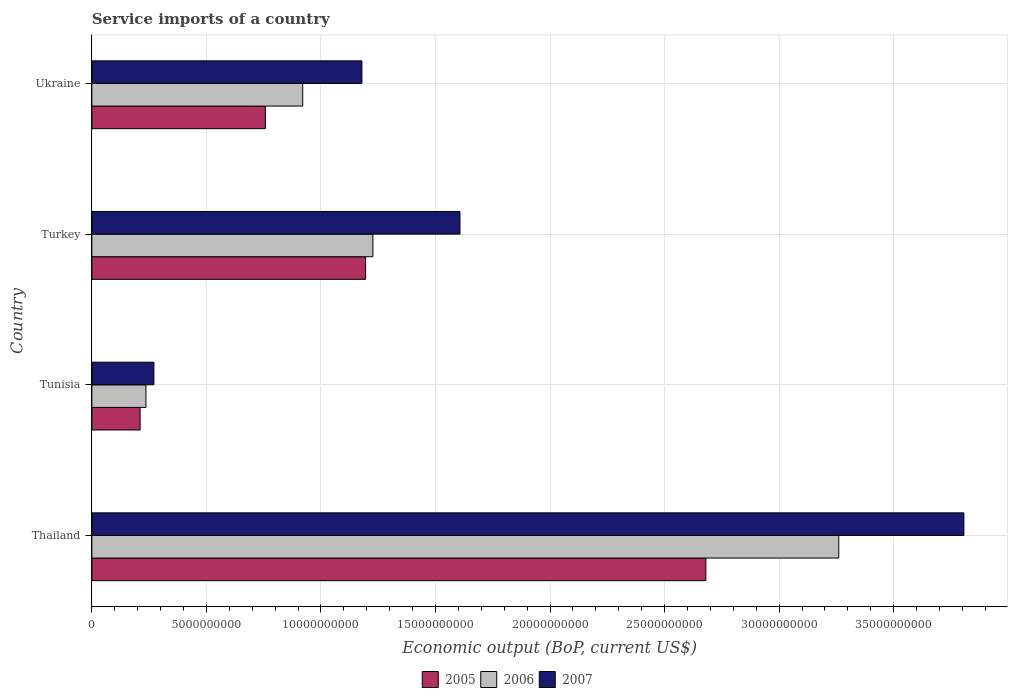How many different coloured bars are there?
Give a very brief answer. 3. Are the number of bars per tick equal to the number of legend labels?
Provide a short and direct response. Yes. What is the service imports in 2006 in Thailand?
Your answer should be compact. 3.26e+1. Across all countries, what is the maximum service imports in 2007?
Ensure brevity in your answer.  3.81e+1. Across all countries, what is the minimum service imports in 2005?
Provide a short and direct response. 2.11e+09. In which country was the service imports in 2006 maximum?
Ensure brevity in your answer.  Thailand. In which country was the service imports in 2007 minimum?
Give a very brief answer. Tunisia. What is the total service imports in 2006 in the graph?
Make the answer very short. 5.64e+1. What is the difference between the service imports in 2005 in Turkey and that in Ukraine?
Offer a terse response. 4.38e+09. What is the difference between the service imports in 2006 in Tunisia and the service imports in 2007 in Turkey?
Make the answer very short. -1.37e+1. What is the average service imports in 2006 per country?
Your response must be concise. 1.41e+1. What is the difference between the service imports in 2005 and service imports in 2006 in Thailand?
Give a very brief answer. -5.80e+09. In how many countries, is the service imports in 2006 greater than 12000000000 US$?
Your response must be concise. 2. What is the ratio of the service imports in 2005 in Thailand to that in Tunisia?
Keep it short and to the point. 12.72. Is the service imports in 2006 in Tunisia less than that in Ukraine?
Make the answer very short. Yes. Is the difference between the service imports in 2005 in Thailand and Turkey greater than the difference between the service imports in 2006 in Thailand and Turkey?
Your response must be concise. No. What is the difference between the highest and the second highest service imports in 2007?
Provide a succinct answer. 2.20e+1. What is the difference between the highest and the lowest service imports in 2007?
Give a very brief answer. 3.54e+1. Is the sum of the service imports in 2007 in Thailand and Tunisia greater than the maximum service imports in 2005 across all countries?
Keep it short and to the point. Yes. What does the 3rd bar from the top in Thailand represents?
Your response must be concise. 2005. Are all the bars in the graph horizontal?
Make the answer very short. Yes. How many countries are there in the graph?
Ensure brevity in your answer.  4. Does the graph contain any zero values?
Make the answer very short. No. How are the legend labels stacked?
Keep it short and to the point. Horizontal. What is the title of the graph?
Provide a short and direct response. Service imports of a country. What is the label or title of the X-axis?
Offer a very short reply. Economic output (BoP, current US$). What is the Economic output (BoP, current US$) in 2005 in Thailand?
Your response must be concise. 2.68e+1. What is the Economic output (BoP, current US$) in 2006 in Thailand?
Ensure brevity in your answer.  3.26e+1. What is the Economic output (BoP, current US$) in 2007 in Thailand?
Provide a short and direct response. 3.81e+1. What is the Economic output (BoP, current US$) in 2005 in Tunisia?
Provide a succinct answer. 2.11e+09. What is the Economic output (BoP, current US$) in 2006 in Tunisia?
Give a very brief answer. 2.36e+09. What is the Economic output (BoP, current US$) in 2007 in Tunisia?
Offer a very short reply. 2.71e+09. What is the Economic output (BoP, current US$) of 2005 in Turkey?
Offer a terse response. 1.20e+1. What is the Economic output (BoP, current US$) in 2006 in Turkey?
Offer a terse response. 1.23e+1. What is the Economic output (BoP, current US$) in 2007 in Turkey?
Keep it short and to the point. 1.61e+1. What is the Economic output (BoP, current US$) in 2005 in Ukraine?
Provide a succinct answer. 7.58e+09. What is the Economic output (BoP, current US$) of 2006 in Ukraine?
Your answer should be compact. 9.20e+09. What is the Economic output (BoP, current US$) in 2007 in Ukraine?
Offer a terse response. 1.18e+1. Across all countries, what is the maximum Economic output (BoP, current US$) of 2005?
Your response must be concise. 2.68e+1. Across all countries, what is the maximum Economic output (BoP, current US$) of 2006?
Provide a succinct answer. 3.26e+1. Across all countries, what is the maximum Economic output (BoP, current US$) of 2007?
Ensure brevity in your answer.  3.81e+1. Across all countries, what is the minimum Economic output (BoP, current US$) in 2005?
Your response must be concise. 2.11e+09. Across all countries, what is the minimum Economic output (BoP, current US$) of 2006?
Make the answer very short. 2.36e+09. Across all countries, what is the minimum Economic output (BoP, current US$) in 2007?
Your answer should be very brief. 2.71e+09. What is the total Economic output (BoP, current US$) of 2005 in the graph?
Keep it short and to the point. 4.84e+1. What is the total Economic output (BoP, current US$) of 2006 in the graph?
Your response must be concise. 5.64e+1. What is the total Economic output (BoP, current US$) of 2007 in the graph?
Give a very brief answer. 6.86e+1. What is the difference between the Economic output (BoP, current US$) of 2005 in Thailand and that in Tunisia?
Provide a short and direct response. 2.47e+1. What is the difference between the Economic output (BoP, current US$) in 2006 in Thailand and that in Tunisia?
Provide a short and direct response. 3.02e+1. What is the difference between the Economic output (BoP, current US$) of 2007 in Thailand and that in Tunisia?
Provide a succinct answer. 3.54e+1. What is the difference between the Economic output (BoP, current US$) in 2005 in Thailand and that in Turkey?
Provide a succinct answer. 1.49e+1. What is the difference between the Economic output (BoP, current US$) in 2006 in Thailand and that in Turkey?
Ensure brevity in your answer.  2.03e+1. What is the difference between the Economic output (BoP, current US$) in 2007 in Thailand and that in Turkey?
Ensure brevity in your answer.  2.20e+1. What is the difference between the Economic output (BoP, current US$) of 2005 in Thailand and that in Ukraine?
Ensure brevity in your answer.  1.92e+1. What is the difference between the Economic output (BoP, current US$) of 2006 in Thailand and that in Ukraine?
Your answer should be very brief. 2.34e+1. What is the difference between the Economic output (BoP, current US$) of 2007 in Thailand and that in Ukraine?
Your response must be concise. 2.63e+1. What is the difference between the Economic output (BoP, current US$) of 2005 in Tunisia and that in Turkey?
Offer a very short reply. -9.84e+09. What is the difference between the Economic output (BoP, current US$) in 2006 in Tunisia and that in Turkey?
Offer a very short reply. -9.91e+09. What is the difference between the Economic output (BoP, current US$) of 2007 in Tunisia and that in Turkey?
Offer a very short reply. -1.34e+1. What is the difference between the Economic output (BoP, current US$) of 2005 in Tunisia and that in Ukraine?
Give a very brief answer. -5.47e+09. What is the difference between the Economic output (BoP, current US$) in 2006 in Tunisia and that in Ukraine?
Give a very brief answer. -6.84e+09. What is the difference between the Economic output (BoP, current US$) of 2007 in Tunisia and that in Ukraine?
Your answer should be compact. -9.08e+09. What is the difference between the Economic output (BoP, current US$) in 2005 in Turkey and that in Ukraine?
Your answer should be very brief. 4.38e+09. What is the difference between the Economic output (BoP, current US$) of 2006 in Turkey and that in Ukraine?
Your response must be concise. 3.06e+09. What is the difference between the Economic output (BoP, current US$) of 2007 in Turkey and that in Ukraine?
Make the answer very short. 4.28e+09. What is the difference between the Economic output (BoP, current US$) in 2005 in Thailand and the Economic output (BoP, current US$) in 2006 in Tunisia?
Your response must be concise. 2.44e+1. What is the difference between the Economic output (BoP, current US$) of 2005 in Thailand and the Economic output (BoP, current US$) of 2007 in Tunisia?
Give a very brief answer. 2.41e+1. What is the difference between the Economic output (BoP, current US$) of 2006 in Thailand and the Economic output (BoP, current US$) of 2007 in Tunisia?
Make the answer very short. 2.99e+1. What is the difference between the Economic output (BoP, current US$) in 2005 in Thailand and the Economic output (BoP, current US$) in 2006 in Turkey?
Give a very brief answer. 1.45e+1. What is the difference between the Economic output (BoP, current US$) in 2005 in Thailand and the Economic output (BoP, current US$) in 2007 in Turkey?
Offer a terse response. 1.07e+1. What is the difference between the Economic output (BoP, current US$) in 2006 in Thailand and the Economic output (BoP, current US$) in 2007 in Turkey?
Offer a very short reply. 1.65e+1. What is the difference between the Economic output (BoP, current US$) in 2005 in Thailand and the Economic output (BoP, current US$) in 2006 in Ukraine?
Provide a succinct answer. 1.76e+1. What is the difference between the Economic output (BoP, current US$) in 2005 in Thailand and the Economic output (BoP, current US$) in 2007 in Ukraine?
Provide a short and direct response. 1.50e+1. What is the difference between the Economic output (BoP, current US$) of 2006 in Thailand and the Economic output (BoP, current US$) of 2007 in Ukraine?
Give a very brief answer. 2.08e+1. What is the difference between the Economic output (BoP, current US$) of 2005 in Tunisia and the Economic output (BoP, current US$) of 2006 in Turkey?
Ensure brevity in your answer.  -1.02e+1. What is the difference between the Economic output (BoP, current US$) of 2005 in Tunisia and the Economic output (BoP, current US$) of 2007 in Turkey?
Make the answer very short. -1.40e+1. What is the difference between the Economic output (BoP, current US$) in 2006 in Tunisia and the Economic output (BoP, current US$) in 2007 in Turkey?
Ensure brevity in your answer.  -1.37e+1. What is the difference between the Economic output (BoP, current US$) in 2005 in Tunisia and the Economic output (BoP, current US$) in 2006 in Ukraine?
Keep it short and to the point. -7.10e+09. What is the difference between the Economic output (BoP, current US$) of 2005 in Tunisia and the Economic output (BoP, current US$) of 2007 in Ukraine?
Give a very brief answer. -9.68e+09. What is the difference between the Economic output (BoP, current US$) of 2006 in Tunisia and the Economic output (BoP, current US$) of 2007 in Ukraine?
Your answer should be very brief. -9.43e+09. What is the difference between the Economic output (BoP, current US$) of 2005 in Turkey and the Economic output (BoP, current US$) of 2006 in Ukraine?
Your answer should be compact. 2.74e+09. What is the difference between the Economic output (BoP, current US$) of 2005 in Turkey and the Economic output (BoP, current US$) of 2007 in Ukraine?
Provide a short and direct response. 1.60e+08. What is the difference between the Economic output (BoP, current US$) in 2006 in Turkey and the Economic output (BoP, current US$) in 2007 in Ukraine?
Ensure brevity in your answer.  4.78e+08. What is the average Economic output (BoP, current US$) in 2005 per country?
Offer a very short reply. 1.21e+1. What is the average Economic output (BoP, current US$) in 2006 per country?
Give a very brief answer. 1.41e+1. What is the average Economic output (BoP, current US$) of 2007 per country?
Your answer should be compact. 1.72e+1. What is the difference between the Economic output (BoP, current US$) in 2005 and Economic output (BoP, current US$) in 2006 in Thailand?
Provide a short and direct response. -5.80e+09. What is the difference between the Economic output (BoP, current US$) in 2005 and Economic output (BoP, current US$) in 2007 in Thailand?
Ensure brevity in your answer.  -1.13e+1. What is the difference between the Economic output (BoP, current US$) in 2006 and Economic output (BoP, current US$) in 2007 in Thailand?
Ensure brevity in your answer.  -5.46e+09. What is the difference between the Economic output (BoP, current US$) in 2005 and Economic output (BoP, current US$) in 2006 in Tunisia?
Keep it short and to the point. -2.55e+08. What is the difference between the Economic output (BoP, current US$) of 2005 and Economic output (BoP, current US$) of 2007 in Tunisia?
Give a very brief answer. -6.03e+08. What is the difference between the Economic output (BoP, current US$) of 2006 and Economic output (BoP, current US$) of 2007 in Tunisia?
Your response must be concise. -3.48e+08. What is the difference between the Economic output (BoP, current US$) of 2005 and Economic output (BoP, current US$) of 2006 in Turkey?
Your response must be concise. -3.18e+08. What is the difference between the Economic output (BoP, current US$) of 2005 and Economic output (BoP, current US$) of 2007 in Turkey?
Keep it short and to the point. -4.12e+09. What is the difference between the Economic output (BoP, current US$) in 2006 and Economic output (BoP, current US$) in 2007 in Turkey?
Your response must be concise. -3.80e+09. What is the difference between the Economic output (BoP, current US$) of 2005 and Economic output (BoP, current US$) of 2006 in Ukraine?
Your answer should be compact. -1.63e+09. What is the difference between the Economic output (BoP, current US$) in 2005 and Economic output (BoP, current US$) in 2007 in Ukraine?
Your answer should be very brief. -4.22e+09. What is the difference between the Economic output (BoP, current US$) in 2006 and Economic output (BoP, current US$) in 2007 in Ukraine?
Your answer should be compact. -2.58e+09. What is the ratio of the Economic output (BoP, current US$) of 2005 in Thailand to that in Tunisia?
Offer a terse response. 12.72. What is the ratio of the Economic output (BoP, current US$) of 2006 in Thailand to that in Tunisia?
Offer a very short reply. 13.8. What is the ratio of the Economic output (BoP, current US$) in 2007 in Thailand to that in Tunisia?
Give a very brief answer. 14.05. What is the ratio of the Economic output (BoP, current US$) in 2005 in Thailand to that in Turkey?
Your response must be concise. 2.24. What is the ratio of the Economic output (BoP, current US$) in 2006 in Thailand to that in Turkey?
Ensure brevity in your answer.  2.66. What is the ratio of the Economic output (BoP, current US$) of 2007 in Thailand to that in Turkey?
Provide a succinct answer. 2.37. What is the ratio of the Economic output (BoP, current US$) in 2005 in Thailand to that in Ukraine?
Your response must be concise. 3.54. What is the ratio of the Economic output (BoP, current US$) of 2006 in Thailand to that in Ukraine?
Provide a short and direct response. 3.54. What is the ratio of the Economic output (BoP, current US$) in 2007 in Thailand to that in Ukraine?
Provide a short and direct response. 3.23. What is the ratio of the Economic output (BoP, current US$) of 2005 in Tunisia to that in Turkey?
Offer a very short reply. 0.18. What is the ratio of the Economic output (BoP, current US$) of 2006 in Tunisia to that in Turkey?
Offer a very short reply. 0.19. What is the ratio of the Economic output (BoP, current US$) of 2007 in Tunisia to that in Turkey?
Provide a succinct answer. 0.17. What is the ratio of the Economic output (BoP, current US$) in 2005 in Tunisia to that in Ukraine?
Offer a terse response. 0.28. What is the ratio of the Economic output (BoP, current US$) of 2006 in Tunisia to that in Ukraine?
Give a very brief answer. 0.26. What is the ratio of the Economic output (BoP, current US$) in 2007 in Tunisia to that in Ukraine?
Your answer should be compact. 0.23. What is the ratio of the Economic output (BoP, current US$) of 2005 in Turkey to that in Ukraine?
Keep it short and to the point. 1.58. What is the ratio of the Economic output (BoP, current US$) in 2006 in Turkey to that in Ukraine?
Ensure brevity in your answer.  1.33. What is the ratio of the Economic output (BoP, current US$) in 2007 in Turkey to that in Ukraine?
Your answer should be compact. 1.36. What is the difference between the highest and the second highest Economic output (BoP, current US$) in 2005?
Offer a very short reply. 1.49e+1. What is the difference between the highest and the second highest Economic output (BoP, current US$) in 2006?
Your answer should be very brief. 2.03e+1. What is the difference between the highest and the second highest Economic output (BoP, current US$) in 2007?
Offer a very short reply. 2.20e+1. What is the difference between the highest and the lowest Economic output (BoP, current US$) of 2005?
Offer a very short reply. 2.47e+1. What is the difference between the highest and the lowest Economic output (BoP, current US$) in 2006?
Offer a terse response. 3.02e+1. What is the difference between the highest and the lowest Economic output (BoP, current US$) of 2007?
Your answer should be very brief. 3.54e+1. 